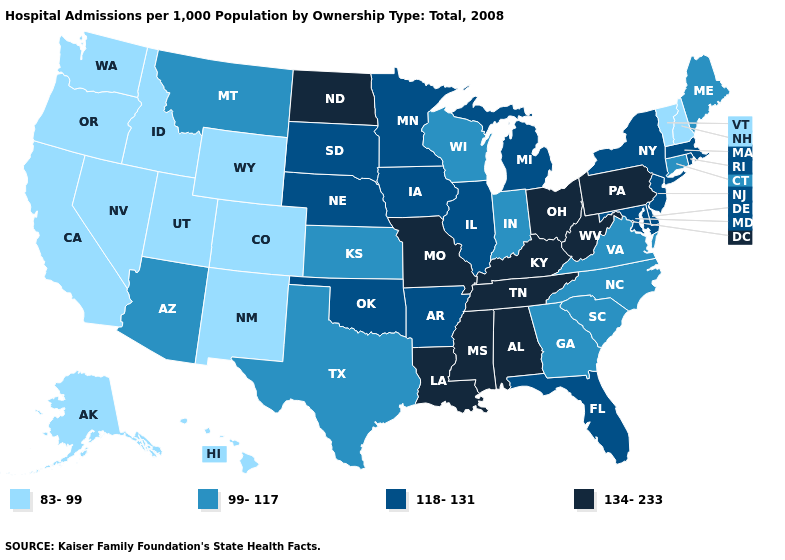Name the states that have a value in the range 134-233?
Answer briefly. Alabama, Kentucky, Louisiana, Mississippi, Missouri, North Dakota, Ohio, Pennsylvania, Tennessee, West Virginia. What is the value of South Carolina?
Answer briefly. 99-117. Name the states that have a value in the range 118-131?
Write a very short answer. Arkansas, Delaware, Florida, Illinois, Iowa, Maryland, Massachusetts, Michigan, Minnesota, Nebraska, New Jersey, New York, Oklahoma, Rhode Island, South Dakota. What is the value of Ohio?
Be succinct. 134-233. Is the legend a continuous bar?
Keep it brief. No. Is the legend a continuous bar?
Answer briefly. No. Does the first symbol in the legend represent the smallest category?
Write a very short answer. Yes. Name the states that have a value in the range 83-99?
Short answer required. Alaska, California, Colorado, Hawaii, Idaho, Nevada, New Hampshire, New Mexico, Oregon, Utah, Vermont, Washington, Wyoming. What is the value of Colorado?
Write a very short answer. 83-99. What is the highest value in the West ?
Be succinct. 99-117. Name the states that have a value in the range 134-233?
Concise answer only. Alabama, Kentucky, Louisiana, Mississippi, Missouri, North Dakota, Ohio, Pennsylvania, Tennessee, West Virginia. Name the states that have a value in the range 83-99?
Quick response, please. Alaska, California, Colorado, Hawaii, Idaho, Nevada, New Hampshire, New Mexico, Oregon, Utah, Vermont, Washington, Wyoming. Does Kentucky have the same value as Mississippi?
Quick response, please. Yes. Among the states that border Maryland , which have the highest value?
Give a very brief answer. Pennsylvania, West Virginia. What is the lowest value in the USA?
Be succinct. 83-99. 